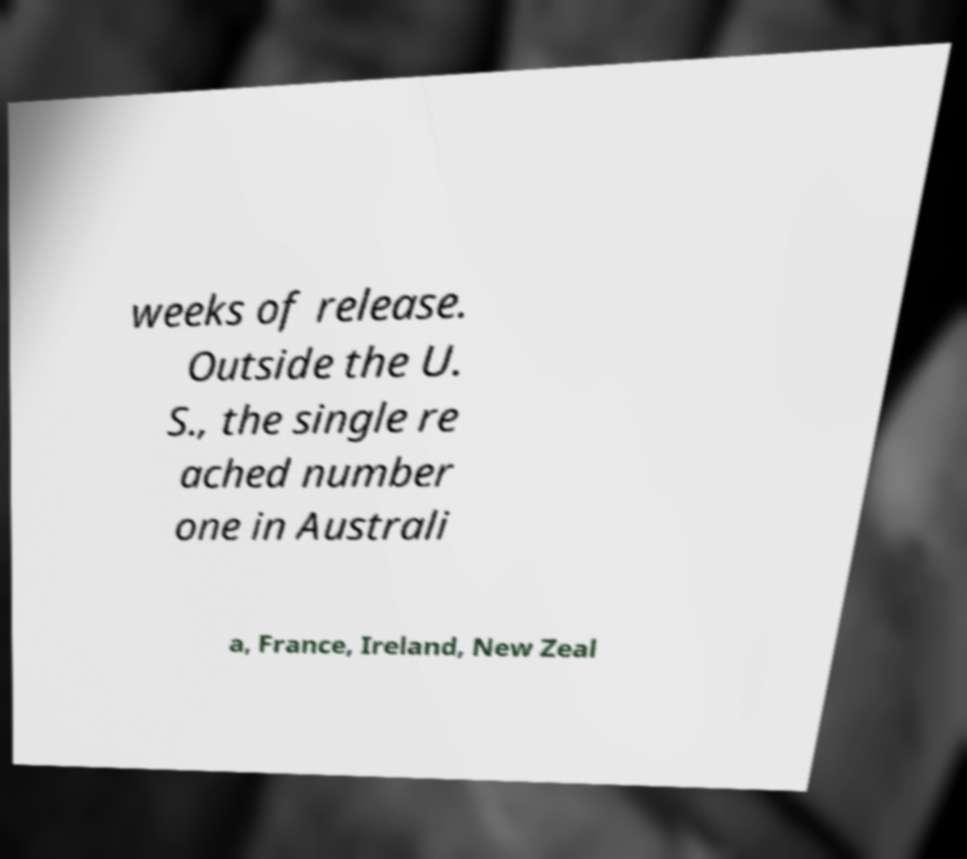For documentation purposes, I need the text within this image transcribed. Could you provide that? weeks of release. Outside the U. S., the single re ached number one in Australi a, France, Ireland, New Zeal 